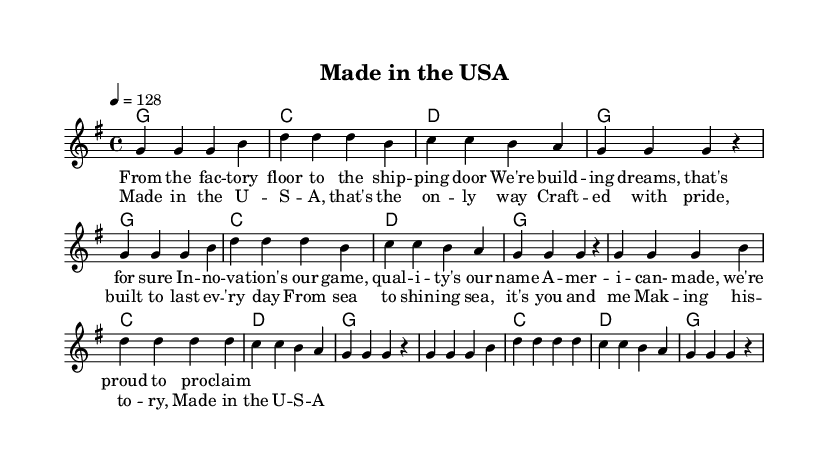What is the key signature of this music? The key signature shown is G major, which indicates one sharp. This can be inferred from the "g" in the global block settings.
Answer: G major What is the time signature of the music? The time signature specified in the global block is 4/4, meaning there are four beats in each measure. This is indicated right after the key signature declaration.
Answer: 4/4 What is the tempo marking? The tempo marking is set to 128 beats per minute, indicated by "4 = 128" in the global settings. This provides the speed at which the piece is to be played.
Answer: 128 How many measures of music are there in the verse? In the verse section, there are 8 measures of music shown, as counted from the notation in the melody section.
Answer: 8 What is the repeated phrase during the chorus? The repeated phrase in the chorus is "Made in the U S A," which is clearly indicated in the lyric mode section of the sheet music.
Answer: Made in the U S A Which theme is emphasized in the lyrics? The lyrics celebrate American manufacturing and innovation, emphasizing pride in creating products domestically. This can be deduced from the phrases describing craftsmanship and quality in the lyrics.
Answer: American manufacturing 